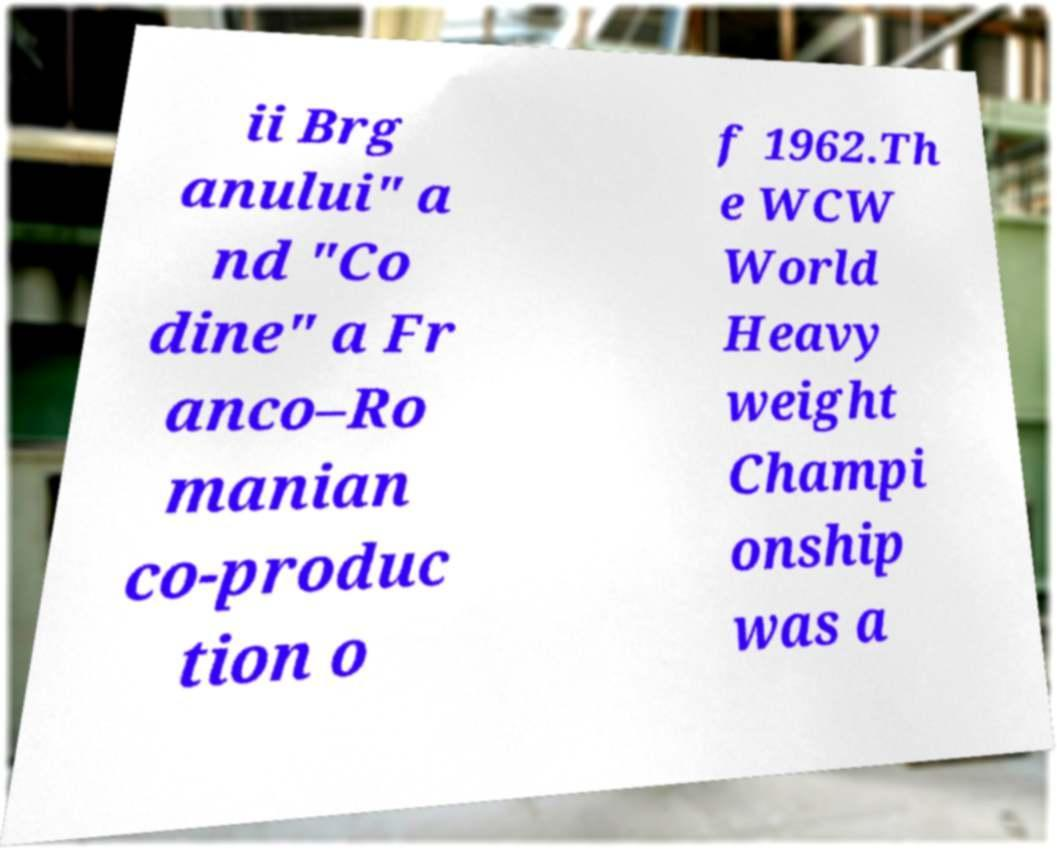Could you assist in decoding the text presented in this image and type it out clearly? ii Brg anului" a nd "Co dine" a Fr anco–Ro manian co-produc tion o f 1962.Th e WCW World Heavy weight Champi onship was a 